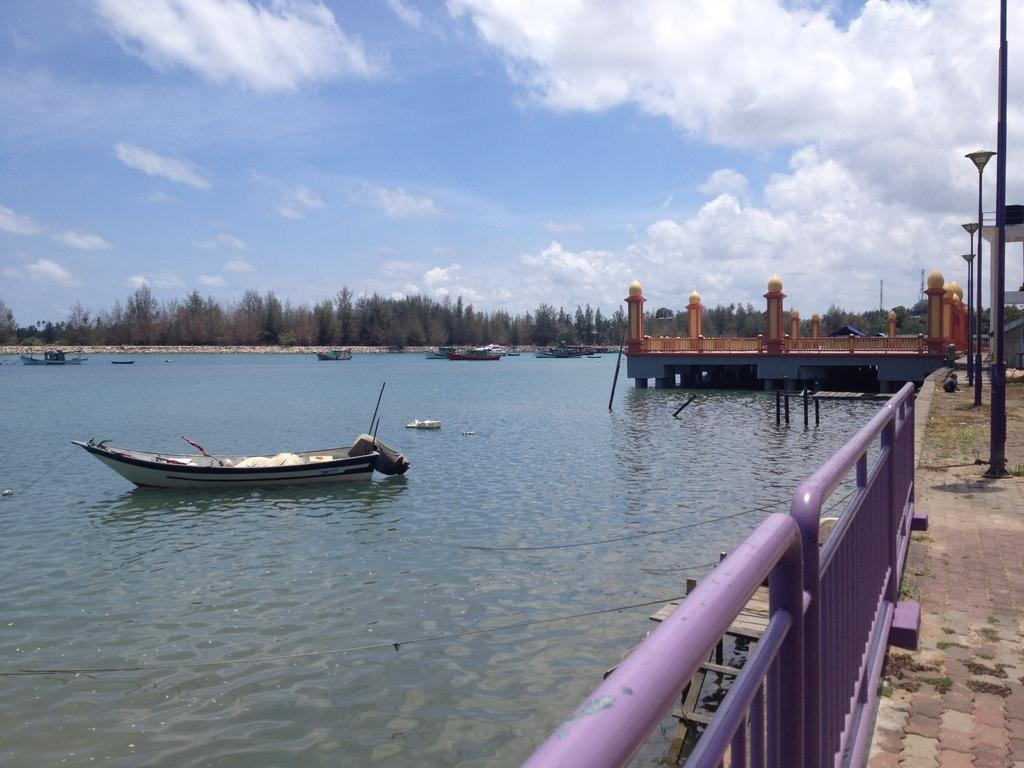What is the main subject of the image? There is a boat on water in the image. What can be seen on the right side of the image? There is a bridge on the right side of the image. What type of vegetation is visible in the background of the image? There is a group of trees in the background of the image. What is visible at the top of the image? The sky is visible at the top of the image. What can be observed in the sky? Clouds are present in the sky. What type of meal is being served in the office in the image? There is no office or meal present in the image; it features a boat on water, a bridge, trees, sky, and clouds. 